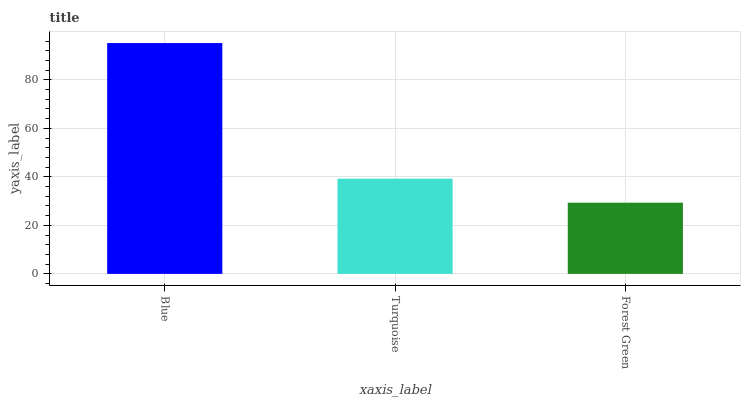Is Forest Green the minimum?
Answer yes or no. Yes. Is Blue the maximum?
Answer yes or no. Yes. Is Turquoise the minimum?
Answer yes or no. No. Is Turquoise the maximum?
Answer yes or no. No. Is Blue greater than Turquoise?
Answer yes or no. Yes. Is Turquoise less than Blue?
Answer yes or no. Yes. Is Turquoise greater than Blue?
Answer yes or no. No. Is Blue less than Turquoise?
Answer yes or no. No. Is Turquoise the high median?
Answer yes or no. Yes. Is Turquoise the low median?
Answer yes or no. Yes. Is Blue the high median?
Answer yes or no. No. Is Forest Green the low median?
Answer yes or no. No. 